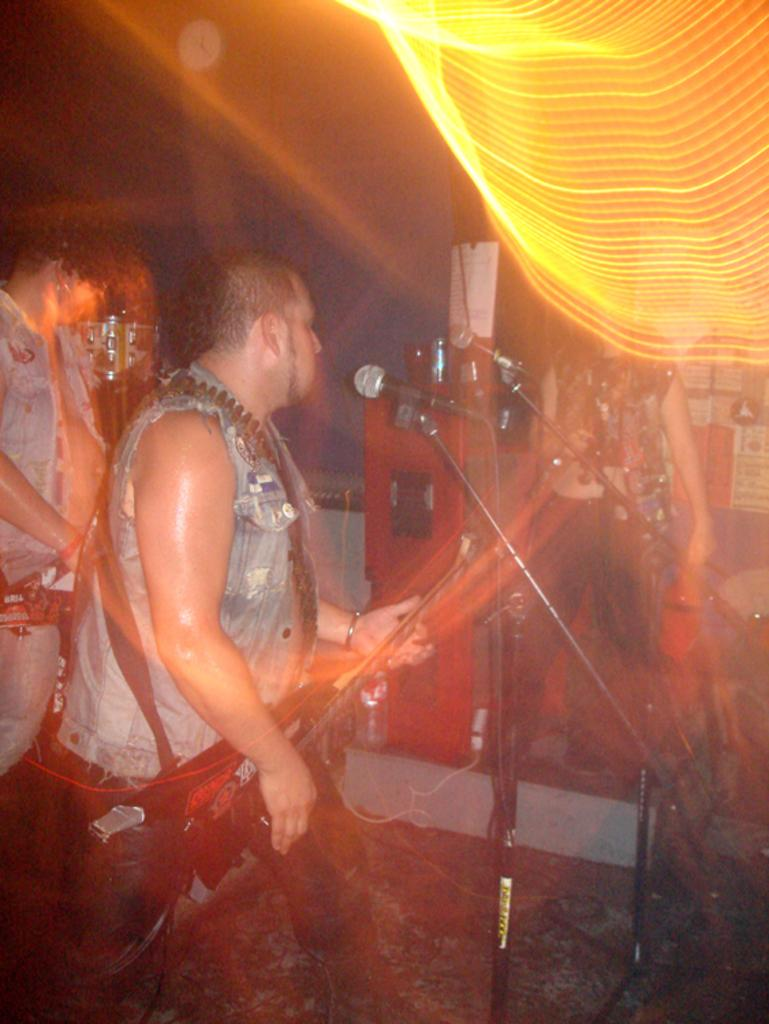What is the main activity of the person in the image? The person in the image is playing the guitar. What is the person playing the guitar standing near? The person is in front of a microphone. Are there any other people in the image? Yes, there are other people in the image. What can be seen in the background or surroundings of the image? There are lights visible in the image. What type of appliance is the person wearing on their head in the image? There is no appliance visible on the person's head in the image. Can you describe the street where the person is playing the guitar in the image? The image does not show a street; it is focused on the person playing the guitar and the surrounding environment. 